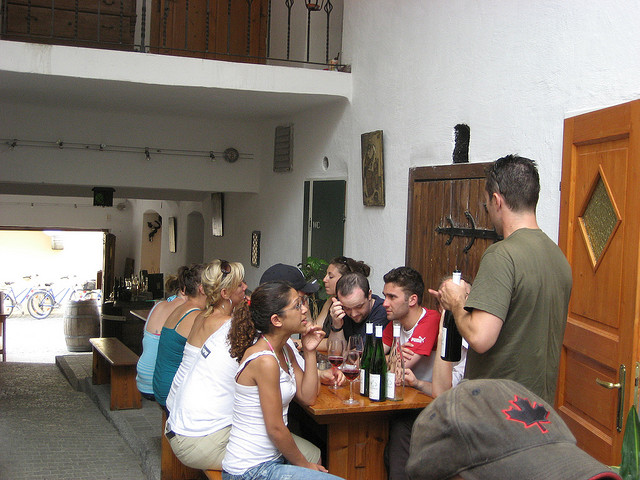<image>What number of boards make up the bench? It is uncertain how many boards make up the bench. It could be one, two, three, or even fifteen. What number of boards make up the bench? I am not sure what number of boards make up the bench. It can be seen as 1, 3, 15 or 2. 